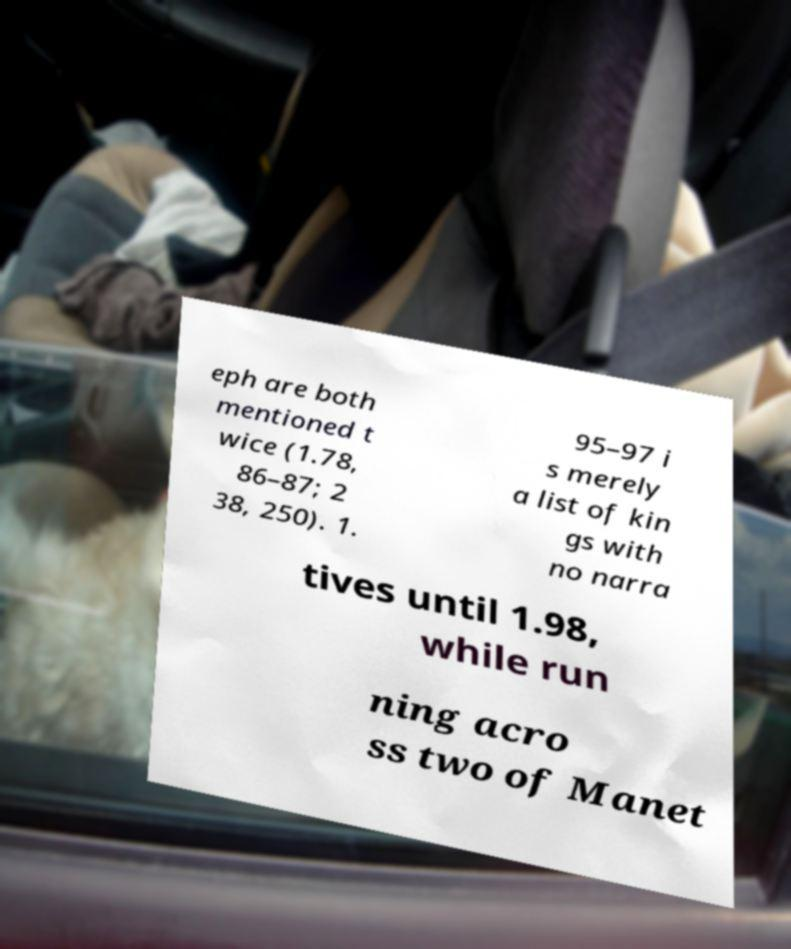For documentation purposes, I need the text within this image transcribed. Could you provide that? eph are both mentioned t wice (1.78, 86–87; 2 38, 250). 1. 95–97 i s merely a list of kin gs with no narra tives until 1.98, while run ning acro ss two of Manet 